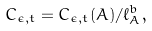<formula> <loc_0><loc_0><loc_500><loc_500>C _ { \epsilon , t } = C _ { \epsilon , t } ( A ) / \ell _ { A } ^ { b } ,</formula> 